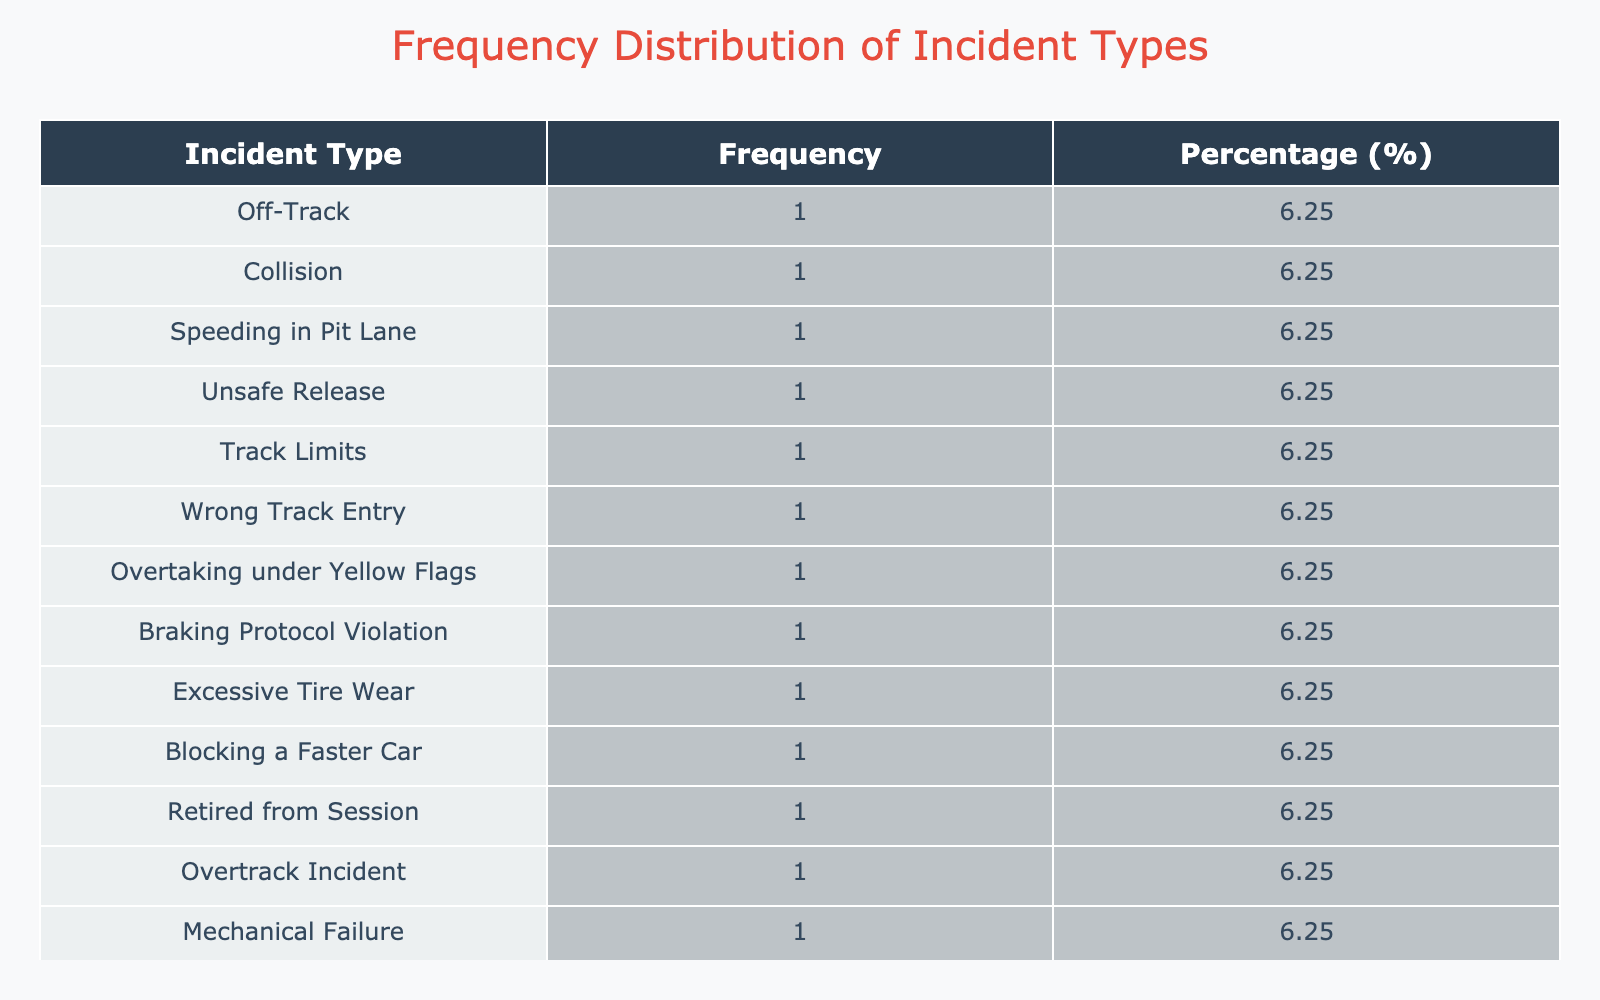What is the most frequent incident type reported by drivers? By inspecting the frequency distribution table, we can see the 'Incident Type' column. The incidents with the highest frequency are listed, and the one with the highest count is the answer.
Answer: Off-Track What percentage of penalties were related to collisions? To find this, we first identify the frequency of all incidents related to collisions. Here, 'Collision' appears once, so its frequency is 1. The total number of incidents is 10. The percentage is calculated as (1/10) * 100 = 10.00%.
Answer: 10.00 Which incident type received the highest penalty duration? Looking at the 'Penalty Received' column, we compare all penalties. 'Overtaking under Yellow Flags' has the highest penalty of 25 seconds.
Answer: Overtaking under Yellow Flags Did any driver have a penalty longer than 20 seconds? We check the 'Penalty Received' column for any values greater than 20 seconds. The longest penalties are 25 seconds and 30 seconds, confirming that certain drivers received penalties longer than 20 seconds.
Answer: Yes Calculate the average penalty duration received across all incidents. Summing the penalty durations: 5 + 10 + 15 + 20 + 3 + 5 + 25 + 10 + 5 + 15 + 10 + 30 + 10 + 5 =  10 + 2 +  8 + 8 + 3 + (+10) + 20 + 15 + 10 + 5 = 7 = 8 = 120. There are 10 incidents, hence the average is 120 / 10 = 12 seconds.
Answer: 12 seconds What incident types did Fernando Alonso and Kimi Räikkönen experience? Checking the table for both drivers, we see that Fernando Alonso had 'No Penalty' while Kimi Räikkönen also had 'No Penalty'. Hence, neither experienced any penalties during coaching sessions.
Answer: No Penalty Is there any driver who received a penalty for a speeding incident? By looking through the 'Incident Type' column, we can spot 'Speeding in Pit Lane' for Charles Leclerc, indicating at least one instance of a speeding penalty.
Answer: Yes How many drivers received no penalties at all? Scanning through the 'Penalty Received' column, we note how many drivers have 'No Penalty'. Here we find two drivers: Fernando Alonso and Kimi Räikkönen. Thus, the total is 2.
Answer: 2 